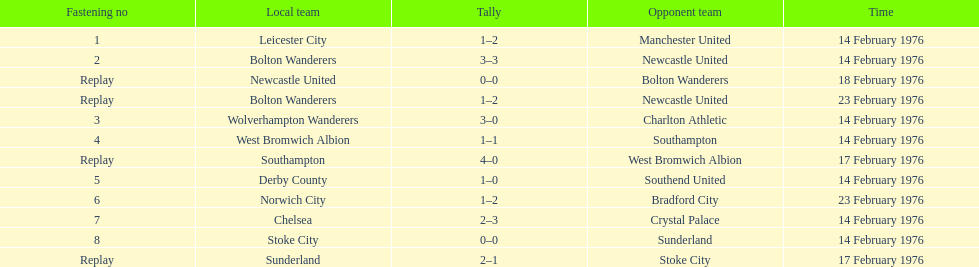Write the full table. {'header': ['Fastening no', 'Local team', 'Tally', 'Opponent team', 'Time'], 'rows': [['1', 'Leicester City', '1–2', 'Manchester United', '14 February 1976'], ['2', 'Bolton Wanderers', '3–3', 'Newcastle United', '14 February 1976'], ['Replay', 'Newcastle United', '0–0', 'Bolton Wanderers', '18 February 1976'], ['Replay', 'Bolton Wanderers', '1–2', 'Newcastle United', '23 February 1976'], ['3', 'Wolverhampton Wanderers', '3–0', 'Charlton Athletic', '14 February 1976'], ['4', 'West Bromwich Albion', '1–1', 'Southampton', '14 February 1976'], ['Replay', 'Southampton', '4–0', 'West Bromwich Albion', '17 February 1976'], ['5', 'Derby County', '1–0', 'Southend United', '14 February 1976'], ['6', 'Norwich City', '1–2', 'Bradford City', '23 February 1976'], ['7', 'Chelsea', '2–3', 'Crystal Palace', '14 February 1976'], ['8', 'Stoke City', '0–0', 'Sunderland', '14 February 1976'], ['Replay', 'Sunderland', '2–1', 'Stoke City', '17 February 1976']]} How many teams played on february 14th, 1976? 7. 